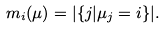<formula> <loc_0><loc_0><loc_500><loc_500>m _ { i } ( \mu ) = | \{ j | \mu _ { j } = i \} | .</formula> 